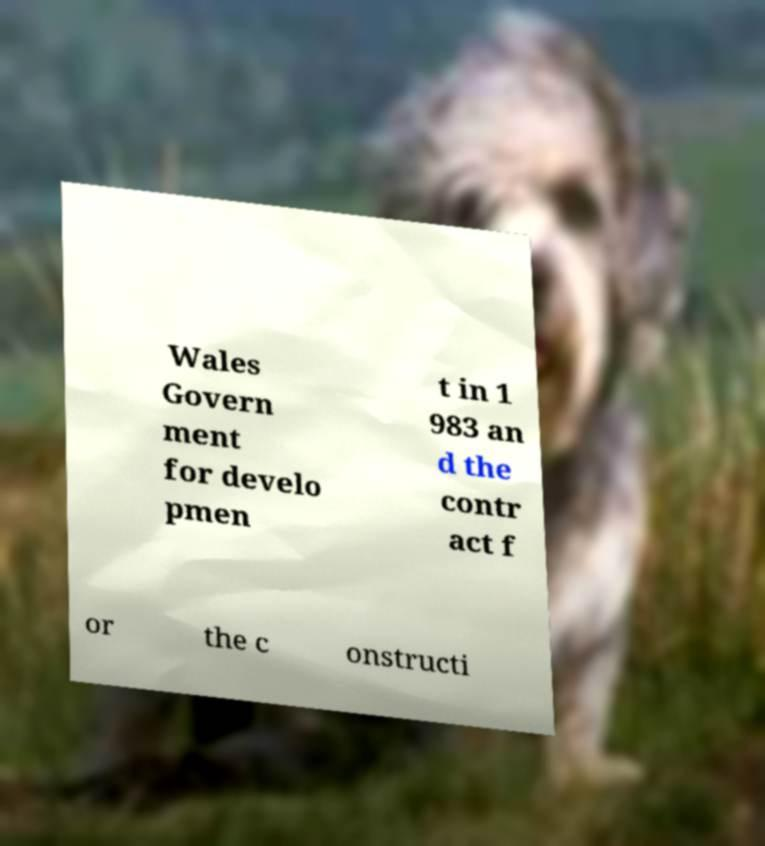Please read and relay the text visible in this image. What does it say? Wales Govern ment for develo pmen t in 1 983 an d the contr act f or the c onstructi 